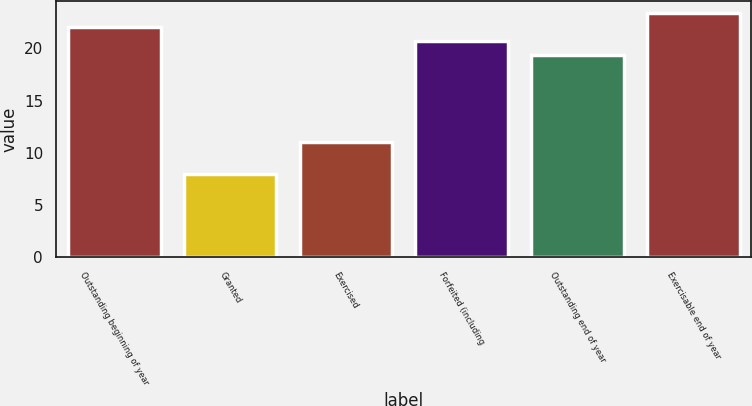Convert chart to OTSL. <chart><loc_0><loc_0><loc_500><loc_500><bar_chart><fcel>Outstanding beginning of year<fcel>Granted<fcel>Exercised<fcel>Forfeited (including<fcel>Outstanding end of year<fcel>Exercisable end of year<nl><fcel>22.04<fcel>7.93<fcel>11.06<fcel>20.69<fcel>19.34<fcel>23.39<nl></chart> 